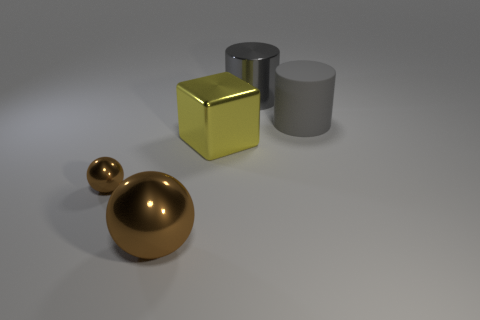Add 5 tiny cubes. How many objects exist? 10 Subtract 1 cubes. How many cubes are left? 0 Subtract all blocks. How many objects are left? 4 Subtract all tiny brown matte cylinders. Subtract all big cylinders. How many objects are left? 3 Add 5 shiny cylinders. How many shiny cylinders are left? 6 Add 4 tiny objects. How many tiny objects exist? 5 Subtract 0 blue spheres. How many objects are left? 5 Subtract all brown cylinders. Subtract all green blocks. How many cylinders are left? 2 